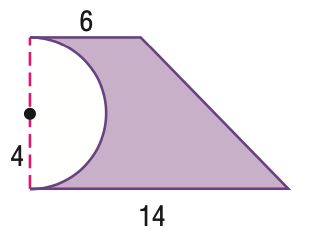Question: Find the area of the figure.
Choices:
A. 22.9
B. 29.7
C. 54.9
D. 60
Answer with the letter. Answer: C 